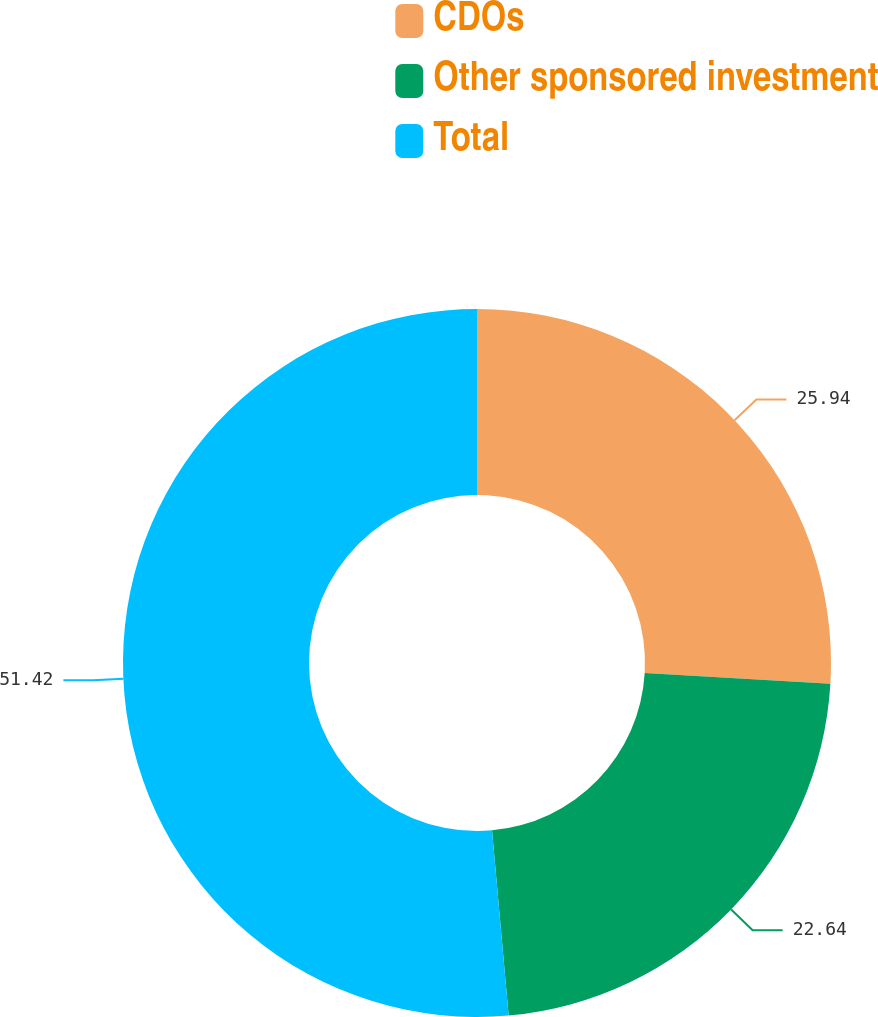Convert chart. <chart><loc_0><loc_0><loc_500><loc_500><pie_chart><fcel>CDOs<fcel>Other sponsored investment<fcel>Total<nl><fcel>25.94%<fcel>22.64%<fcel>51.43%<nl></chart> 